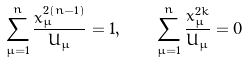<formula> <loc_0><loc_0><loc_500><loc_500>\sum _ { \mu = 1 } ^ { n } \frac { x _ { \mu } ^ { 2 ( n - 1 ) } } { U _ { \mu } } = 1 , \quad \sum _ { \mu = 1 } ^ { n } \frac { x _ { \mu } ^ { 2 k } } { U _ { \mu } } = 0</formula> 